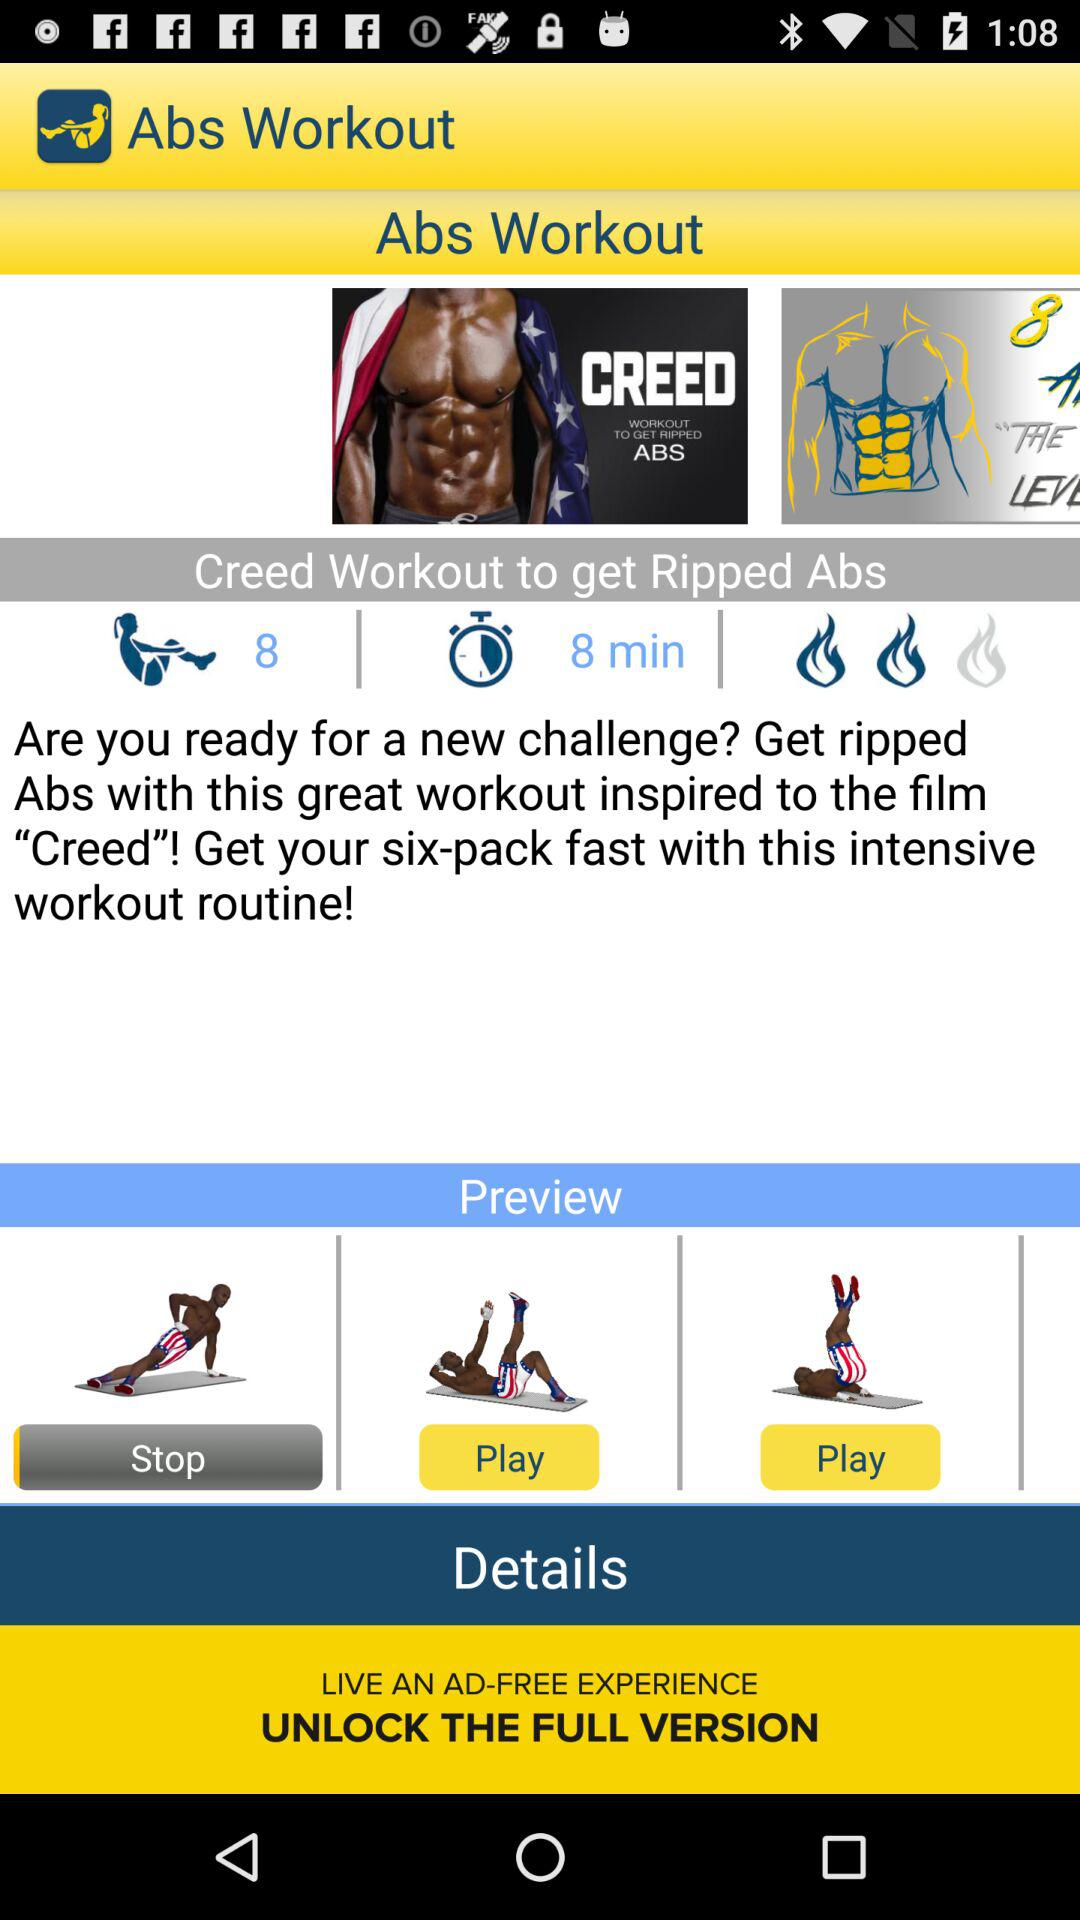How many members are in creed workout?
When the provided information is insufficient, respond with <no answer>. <no answer> 